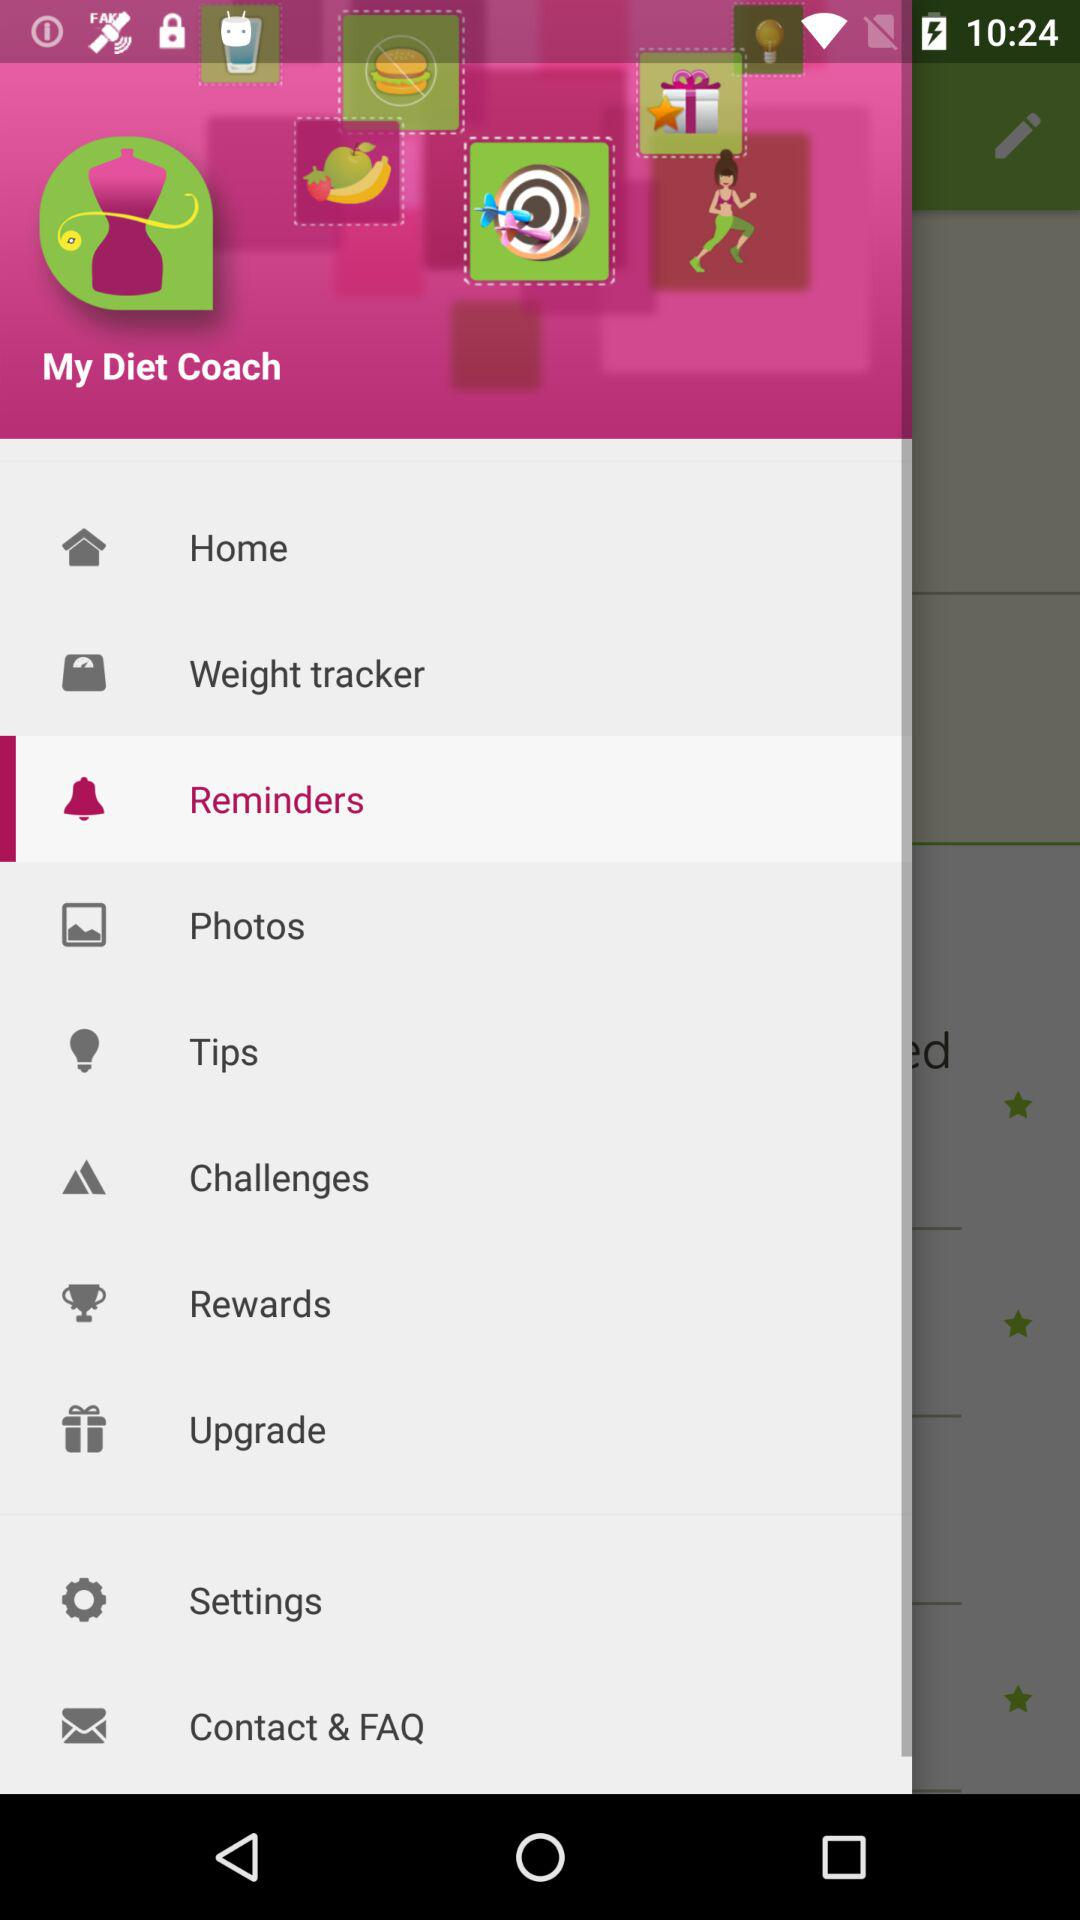Which is the selected item in the menu? The selected item in the menu is "Reminders". 